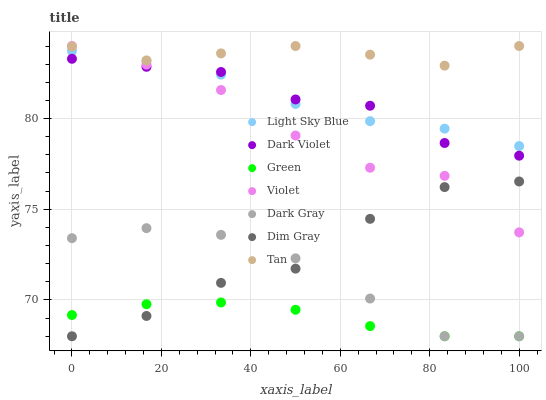Does Green have the minimum area under the curve?
Answer yes or no. Yes. Does Tan have the maximum area under the curve?
Answer yes or no. Yes. Does Dark Violet have the minimum area under the curve?
Answer yes or no. No. Does Dark Violet have the maximum area under the curve?
Answer yes or no. No. Is Green the smoothest?
Answer yes or no. Yes. Is Violet the roughest?
Answer yes or no. Yes. Is Dark Violet the smoothest?
Answer yes or no. No. Is Dark Violet the roughest?
Answer yes or no. No. Does Dim Gray have the lowest value?
Answer yes or no. Yes. Does Dark Violet have the lowest value?
Answer yes or no. No. Does Tan have the highest value?
Answer yes or no. Yes. Does Dark Violet have the highest value?
Answer yes or no. No. Is Dark Gray less than Dark Violet?
Answer yes or no. Yes. Is Tan greater than Green?
Answer yes or no. Yes. Does Green intersect Dim Gray?
Answer yes or no. Yes. Is Green less than Dim Gray?
Answer yes or no. No. Is Green greater than Dim Gray?
Answer yes or no. No. Does Dark Gray intersect Dark Violet?
Answer yes or no. No. 